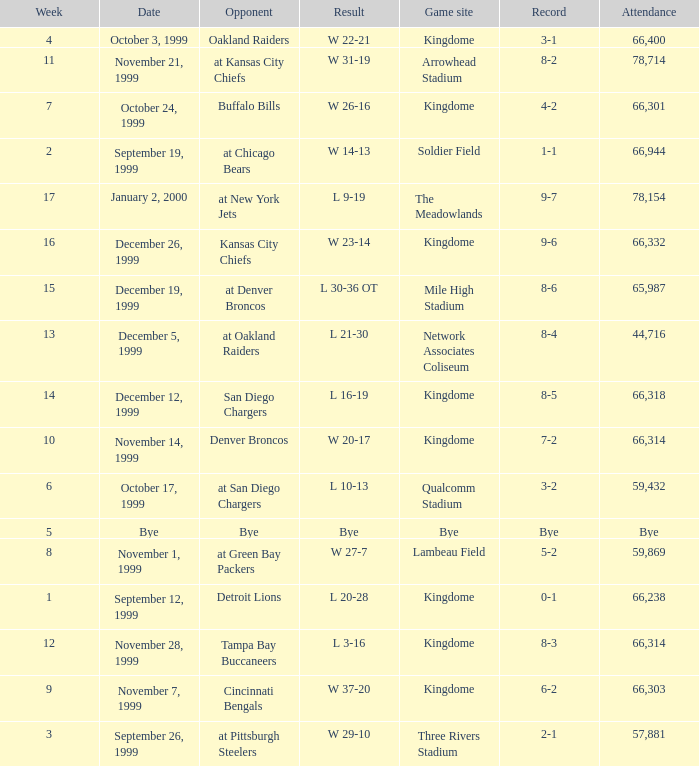For the game that was played on week 2, what is the record? 1-1. 